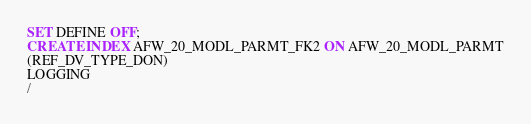<code> <loc_0><loc_0><loc_500><loc_500><_SQL_>SET DEFINE OFF;
CREATE INDEX AFW_20_MODL_PARMT_FK2 ON AFW_20_MODL_PARMT
(REF_DV_TYPE_DON)
LOGGING
/
</code> 